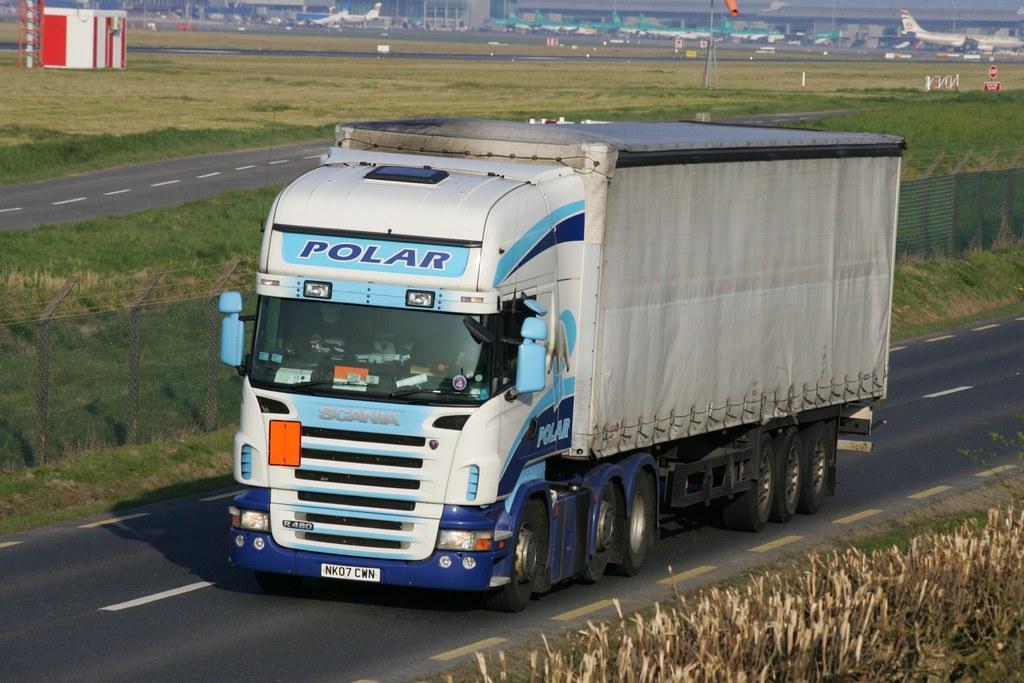Could you give a brief overview of what you see in this image? In this image we can see a motor vehicle on the road, grass, aeroplanes, buildings and information boards. 